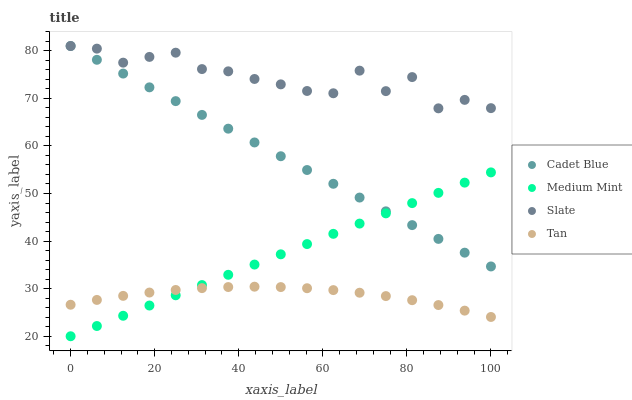Does Tan have the minimum area under the curve?
Answer yes or no. Yes. Does Slate have the maximum area under the curve?
Answer yes or no. Yes. Does Cadet Blue have the minimum area under the curve?
Answer yes or no. No. Does Cadet Blue have the maximum area under the curve?
Answer yes or no. No. Is Medium Mint the smoothest?
Answer yes or no. Yes. Is Slate the roughest?
Answer yes or no. Yes. Is Cadet Blue the smoothest?
Answer yes or no. No. Is Cadet Blue the roughest?
Answer yes or no. No. Does Medium Mint have the lowest value?
Answer yes or no. Yes. Does Cadet Blue have the lowest value?
Answer yes or no. No. Does Cadet Blue have the highest value?
Answer yes or no. Yes. Does Tan have the highest value?
Answer yes or no. No. Is Tan less than Slate?
Answer yes or no. Yes. Is Slate greater than Tan?
Answer yes or no. Yes. Does Tan intersect Medium Mint?
Answer yes or no. Yes. Is Tan less than Medium Mint?
Answer yes or no. No. Is Tan greater than Medium Mint?
Answer yes or no. No. Does Tan intersect Slate?
Answer yes or no. No. 